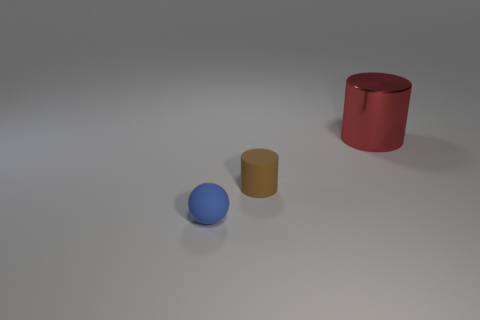There is a rubber ball; is its size the same as the cylinder that is in front of the big red shiny thing?
Give a very brief answer. Yes. What number of objects are either small blue matte objects or red rubber things?
Make the answer very short. 1. What number of other things are the same size as the blue matte thing?
Offer a very short reply. 1. There is a metal thing; is it the same color as the cylinder on the left side of the red cylinder?
Ensure brevity in your answer.  No. What number of cylinders are tiny red shiny things or small brown objects?
Offer a very short reply. 1. Are there any other things that are the same color as the tiny matte sphere?
Give a very brief answer. No. There is a tiny thing that is to the right of the tiny thing in front of the brown matte thing; what is it made of?
Make the answer very short. Rubber. Do the brown cylinder and the object behind the matte cylinder have the same material?
Your response must be concise. No. What number of things are either things that are in front of the large red shiny object or large red metallic cylinders?
Make the answer very short. 3. Is there a tiny sphere of the same color as the large metallic cylinder?
Your response must be concise. No. 